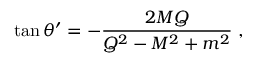Convert formula to latex. <formula><loc_0><loc_0><loc_500><loc_500>\tan \theta ^ { \prime } = - { \frac { 2 M Q } { Q ^ { 2 } - M ^ { 2 } + m ^ { 2 } } } \ ,</formula> 